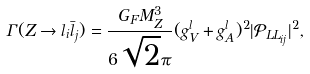Convert formula to latex. <formula><loc_0><loc_0><loc_500><loc_500>\Gamma ( Z \to l _ { i } \bar { l } _ { j } ) = \frac { G _ { F } M _ { Z } ^ { 3 } } { 6 \sqrt { 2 } \pi } ( { g _ { V } ^ { l } + g _ { A } ^ { l } } ) ^ { 2 } | { \mathcal { P } _ { L L _ { i j } } } | ^ { 2 } ,</formula> 